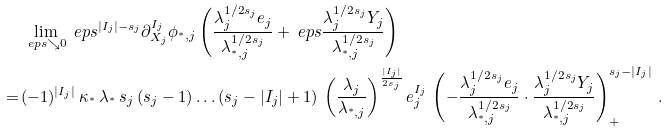Convert formula to latex. <formula><loc_0><loc_0><loc_500><loc_500>& \lim _ { \ e p s \searrow 0 } \ e p s ^ { | I _ { j } | - s _ { j } } \partial ^ { I _ { j } } _ { X _ { j } } \phi _ { ^ { * } , j } \left ( \frac { \lambda _ { j } ^ { 1 / 2 s _ { j } } e _ { j } } { \lambda _ { ^ { * } , j } ^ { 1 / 2 s _ { j } } } + \ e p s \frac { \lambda _ { j } ^ { 1 / 2 s _ { j } } Y _ { j } } { \lambda _ { ^ { * } , j } ^ { 1 / 2 s _ { j } } } \right ) \\ = \, & ( - 1 ) ^ { | I _ { j } | } \, \kappa _ { ^ { * } } \, \lambda _ { ^ { * } } \, s _ { j } \, ( s _ { j } - 1 ) \dots ( s _ { j } - | I _ { j } | + 1 ) \, \left ( \frac { \lambda _ { j } } { \lambda _ { ^ { * } , j } } \right ) ^ { \frac { | I _ { j } | } { 2 s _ { j } } } e _ { j } ^ { I _ { j } } \, \left ( - \frac { \lambda _ { j } ^ { 1 / 2 s _ { j } } e _ { j } } { \lambda _ { ^ { * } , j } ^ { 1 / 2 s _ { j } } } \cdot \frac { \lambda _ { j } ^ { 1 / 2 s _ { j } } Y _ { j } } { \lambda _ { ^ { * } , j } ^ { 1 / 2 s _ { j } } } \right ) _ { + } ^ { s _ { j } - | I _ { j } | } \, .</formula> 